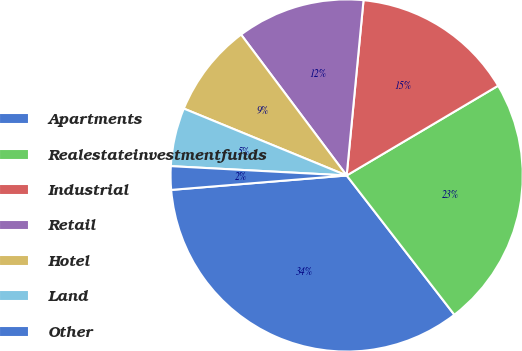Convert chart. <chart><loc_0><loc_0><loc_500><loc_500><pie_chart><fcel>Apartments<fcel>Realestateinvestmentfunds<fcel>Industrial<fcel>Retail<fcel>Hotel<fcel>Land<fcel>Other<nl><fcel>34.17%<fcel>23.04%<fcel>14.96%<fcel>11.76%<fcel>8.56%<fcel>5.36%<fcel>2.15%<nl></chart> 